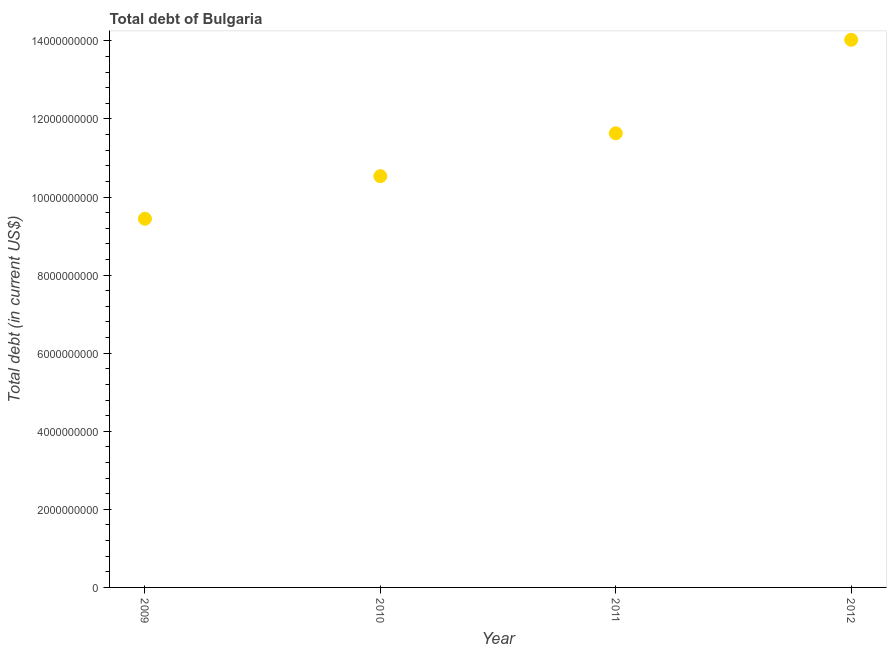What is the total debt in 2012?
Keep it short and to the point. 1.40e+1. Across all years, what is the maximum total debt?
Make the answer very short. 1.40e+1. Across all years, what is the minimum total debt?
Offer a terse response. 9.44e+09. In which year was the total debt minimum?
Provide a succinct answer. 2009. What is the sum of the total debt?
Offer a very short reply. 4.56e+1. What is the difference between the total debt in 2010 and 2011?
Give a very brief answer. -1.10e+09. What is the average total debt per year?
Give a very brief answer. 1.14e+1. What is the median total debt?
Ensure brevity in your answer.  1.11e+1. Do a majority of the years between 2011 and 2010 (inclusive) have total debt greater than 6800000000 US$?
Your answer should be compact. No. What is the ratio of the total debt in 2009 to that in 2010?
Offer a very short reply. 0.9. Is the total debt in 2010 less than that in 2012?
Your response must be concise. Yes. What is the difference between the highest and the second highest total debt?
Give a very brief answer. 2.40e+09. What is the difference between the highest and the lowest total debt?
Your answer should be very brief. 4.58e+09. Does the total debt monotonically increase over the years?
Give a very brief answer. Yes. How many years are there in the graph?
Provide a short and direct response. 4. What is the difference between two consecutive major ticks on the Y-axis?
Keep it short and to the point. 2.00e+09. Are the values on the major ticks of Y-axis written in scientific E-notation?
Keep it short and to the point. No. Does the graph contain any zero values?
Your answer should be compact. No. Does the graph contain grids?
Your answer should be very brief. No. What is the title of the graph?
Provide a succinct answer. Total debt of Bulgaria. What is the label or title of the Y-axis?
Offer a very short reply. Total debt (in current US$). What is the Total debt (in current US$) in 2009?
Your answer should be compact. 9.44e+09. What is the Total debt (in current US$) in 2010?
Your answer should be very brief. 1.05e+1. What is the Total debt (in current US$) in 2011?
Provide a succinct answer. 1.16e+1. What is the Total debt (in current US$) in 2012?
Provide a succinct answer. 1.40e+1. What is the difference between the Total debt (in current US$) in 2009 and 2010?
Ensure brevity in your answer.  -1.09e+09. What is the difference between the Total debt (in current US$) in 2009 and 2011?
Your response must be concise. -2.19e+09. What is the difference between the Total debt (in current US$) in 2009 and 2012?
Make the answer very short. -4.58e+09. What is the difference between the Total debt (in current US$) in 2010 and 2011?
Offer a very short reply. -1.10e+09. What is the difference between the Total debt (in current US$) in 2010 and 2012?
Ensure brevity in your answer.  -3.49e+09. What is the difference between the Total debt (in current US$) in 2011 and 2012?
Your response must be concise. -2.40e+09. What is the ratio of the Total debt (in current US$) in 2009 to that in 2010?
Make the answer very short. 0.9. What is the ratio of the Total debt (in current US$) in 2009 to that in 2011?
Ensure brevity in your answer.  0.81. What is the ratio of the Total debt (in current US$) in 2009 to that in 2012?
Provide a short and direct response. 0.67. What is the ratio of the Total debt (in current US$) in 2010 to that in 2011?
Your answer should be compact. 0.91. What is the ratio of the Total debt (in current US$) in 2010 to that in 2012?
Provide a succinct answer. 0.75. What is the ratio of the Total debt (in current US$) in 2011 to that in 2012?
Ensure brevity in your answer.  0.83. 